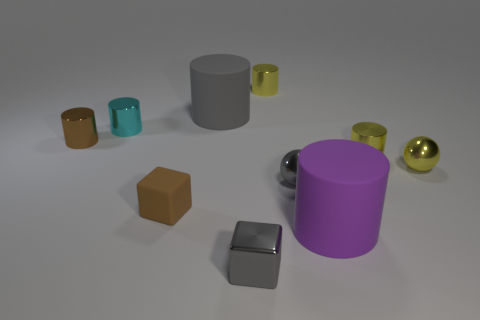Is the number of metal cylinders in front of the small brown shiny object greater than the number of big purple spheres?
Keep it short and to the point. Yes. What shape is the thing that is the same color as the small matte block?
Your answer should be very brief. Cylinder. How many cubes are either big things or purple rubber objects?
Provide a short and direct response. 0. What is the color of the metallic cylinder behind the big object behind the purple matte cylinder?
Make the answer very short. Yellow. Do the small rubber object and the matte thing right of the big gray rubber object have the same color?
Make the answer very short. No. There is a purple cylinder that is made of the same material as the brown block; what is its size?
Offer a very short reply. Large. The cylinder that is the same color as the small rubber block is what size?
Ensure brevity in your answer.  Small. Is there a tiny yellow cylinder that is right of the tiny rubber thing on the left side of the tiny metallic thing in front of the large purple cylinder?
Your answer should be compact. Yes. How many gray balls are the same size as the gray cylinder?
Give a very brief answer. 0. There is a matte cylinder left of the purple object; is its size the same as the brown object that is behind the small brown cube?
Offer a very short reply. No. 